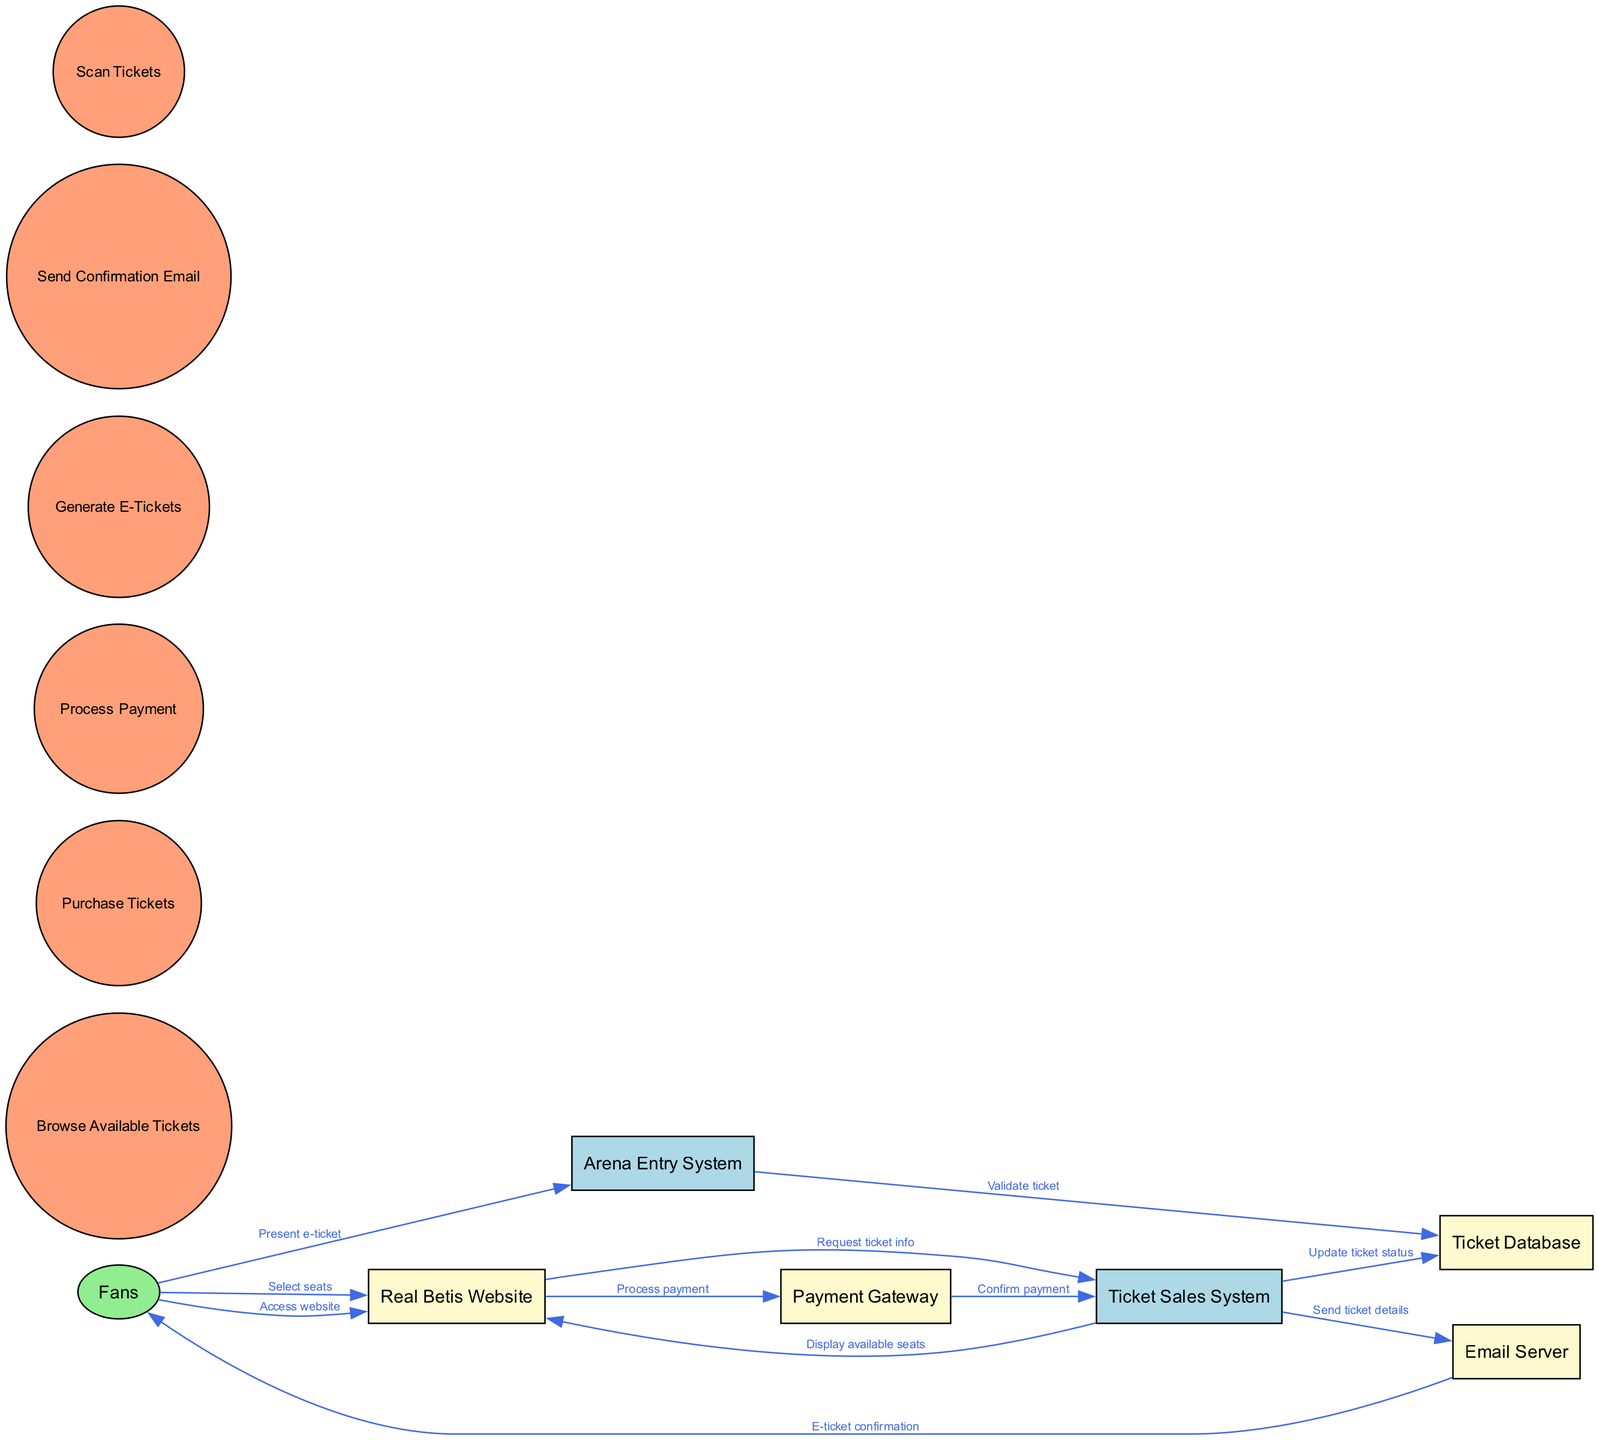What is the first step for Fans in the ticket sales workflow? The first step for Fans is to access the Real Betis Website, as indicated by the flow starting from the Fans node to the Real Betis Website.
Answer: Access website How many processes are involved in the ticket sales system? There are six processes indicated in the diagram, as listed under the processes section of the data provided.
Answer: Six Which system confirms the payment after the payment is processed? The Payment Gateway confirms the payment, as shown by the flow where the Payment Gateway sends a confirmation to the Ticket Sales System.
Answer: Payment Gateway What does the Email Server send to Fans? The Email Server sends an e-ticket confirmation to Fans, as depicted in the flow from the Email Server to the Fans.
Answer: E-ticket confirmation How does the Ticket Sales System update the ticket status? The Ticket Sales System updates the ticket status by communicating with the Ticket Database, as shown in the data flow from Ticket Sales System to Ticket Database.
Answer: Update ticket status What is the role of the Arena Entry System in the workflow? The role of the Arena Entry System is to validate the ticket, which occurs when Fans present their e-ticket to the system.
Answer: Validate ticket What is the total number of entities in the diagram? There are seven entities identified in the diagram, representing different components in the workflow.
Answer: Seven Which node displays available seats to fans? The Real Betis Website displays available seats to Fans, as described in the flow connecting the Ticket Sales System back to the Real Betis Website.
Answer: Real Betis Website How do Fans select their seats in the workflow? Fans select their seats through the Real Betis Website after requesting ticket information, as indicated by the flow from Fans to the Real Betis Website.
Answer: Select seats 